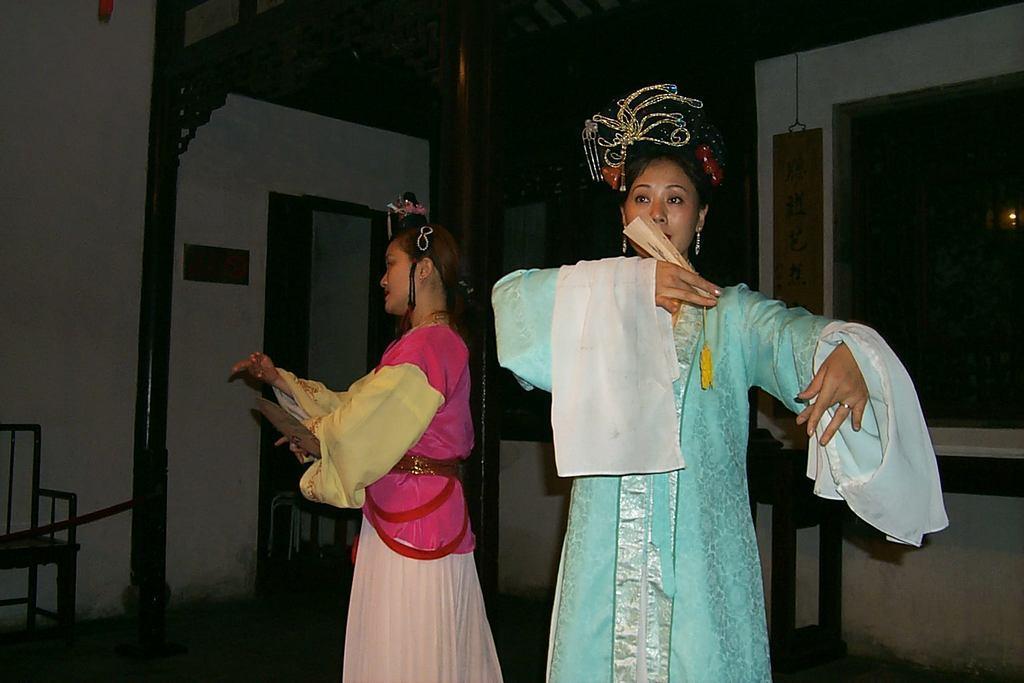Could you give a brief overview of what you see in this image? In this picture there are two girls in the center of the image, they are dancing and there is a chair on the left side of the image, there is a door in the background area of the image and there is a window on the right side of the image. 